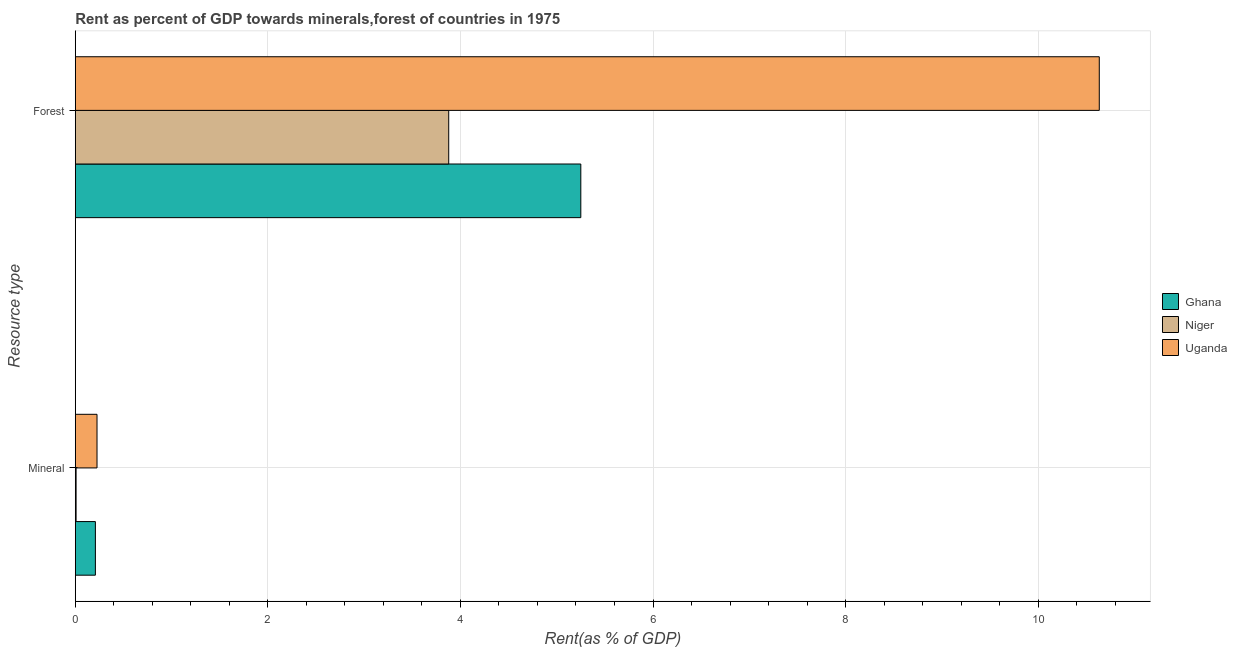How many different coloured bars are there?
Make the answer very short. 3. Are the number of bars per tick equal to the number of legend labels?
Your answer should be very brief. Yes. Are the number of bars on each tick of the Y-axis equal?
Keep it short and to the point. Yes. What is the label of the 1st group of bars from the top?
Ensure brevity in your answer.  Forest. What is the forest rent in Ghana?
Make the answer very short. 5.25. Across all countries, what is the maximum mineral rent?
Offer a terse response. 0.23. Across all countries, what is the minimum forest rent?
Your response must be concise. 3.88. In which country was the mineral rent maximum?
Offer a very short reply. Uganda. In which country was the forest rent minimum?
Your answer should be very brief. Niger. What is the total mineral rent in the graph?
Give a very brief answer. 0.44. What is the difference between the forest rent in Ghana and that in Uganda?
Give a very brief answer. -5.38. What is the difference between the forest rent in Niger and the mineral rent in Ghana?
Keep it short and to the point. 3.67. What is the average forest rent per country?
Keep it short and to the point. 6.59. What is the difference between the mineral rent and forest rent in Ghana?
Offer a terse response. -5.04. In how many countries, is the mineral rent greater than 2.8 %?
Offer a very short reply. 0. What is the ratio of the mineral rent in Niger to that in Uganda?
Your answer should be compact. 0.04. Is the mineral rent in Uganda less than that in Ghana?
Your answer should be very brief. No. In how many countries, is the mineral rent greater than the average mineral rent taken over all countries?
Your answer should be very brief. 2. What does the 3rd bar from the top in Forest represents?
Offer a very short reply. Ghana. What does the 2nd bar from the bottom in Forest represents?
Your answer should be compact. Niger. Are the values on the major ticks of X-axis written in scientific E-notation?
Your answer should be compact. No. Does the graph contain any zero values?
Offer a very short reply. No. Does the graph contain grids?
Give a very brief answer. Yes. Where does the legend appear in the graph?
Offer a terse response. Center right. How many legend labels are there?
Your answer should be very brief. 3. What is the title of the graph?
Your response must be concise. Rent as percent of GDP towards minerals,forest of countries in 1975. What is the label or title of the X-axis?
Your answer should be compact. Rent(as % of GDP). What is the label or title of the Y-axis?
Provide a succinct answer. Resource type. What is the Rent(as % of GDP) of Ghana in Mineral?
Your answer should be very brief. 0.21. What is the Rent(as % of GDP) of Niger in Mineral?
Give a very brief answer. 0.01. What is the Rent(as % of GDP) of Uganda in Mineral?
Offer a terse response. 0.23. What is the Rent(as % of GDP) of Ghana in Forest?
Offer a very short reply. 5.25. What is the Rent(as % of GDP) of Niger in Forest?
Ensure brevity in your answer.  3.88. What is the Rent(as % of GDP) of Uganda in Forest?
Your answer should be compact. 10.63. Across all Resource type, what is the maximum Rent(as % of GDP) of Ghana?
Your answer should be very brief. 5.25. Across all Resource type, what is the maximum Rent(as % of GDP) in Niger?
Your answer should be compact. 3.88. Across all Resource type, what is the maximum Rent(as % of GDP) in Uganda?
Your answer should be very brief. 10.63. Across all Resource type, what is the minimum Rent(as % of GDP) of Ghana?
Offer a terse response. 0.21. Across all Resource type, what is the minimum Rent(as % of GDP) of Niger?
Offer a terse response. 0.01. Across all Resource type, what is the minimum Rent(as % of GDP) in Uganda?
Offer a very short reply. 0.23. What is the total Rent(as % of GDP) of Ghana in the graph?
Give a very brief answer. 5.46. What is the total Rent(as % of GDP) of Niger in the graph?
Give a very brief answer. 3.89. What is the total Rent(as % of GDP) in Uganda in the graph?
Your answer should be compact. 10.86. What is the difference between the Rent(as % of GDP) of Ghana in Mineral and that in Forest?
Offer a very short reply. -5.04. What is the difference between the Rent(as % of GDP) in Niger in Mineral and that in Forest?
Keep it short and to the point. -3.87. What is the difference between the Rent(as % of GDP) of Uganda in Mineral and that in Forest?
Offer a terse response. -10.41. What is the difference between the Rent(as % of GDP) of Ghana in Mineral and the Rent(as % of GDP) of Niger in Forest?
Provide a short and direct response. -3.67. What is the difference between the Rent(as % of GDP) in Ghana in Mineral and the Rent(as % of GDP) in Uganda in Forest?
Keep it short and to the point. -10.43. What is the difference between the Rent(as % of GDP) of Niger in Mineral and the Rent(as % of GDP) of Uganda in Forest?
Provide a succinct answer. -10.63. What is the average Rent(as % of GDP) of Ghana per Resource type?
Your answer should be compact. 2.73. What is the average Rent(as % of GDP) of Niger per Resource type?
Provide a short and direct response. 1.94. What is the average Rent(as % of GDP) in Uganda per Resource type?
Your response must be concise. 5.43. What is the difference between the Rent(as % of GDP) of Ghana and Rent(as % of GDP) of Niger in Mineral?
Ensure brevity in your answer.  0.2. What is the difference between the Rent(as % of GDP) in Ghana and Rent(as % of GDP) in Uganda in Mineral?
Provide a succinct answer. -0.02. What is the difference between the Rent(as % of GDP) in Niger and Rent(as % of GDP) in Uganda in Mineral?
Offer a terse response. -0.22. What is the difference between the Rent(as % of GDP) of Ghana and Rent(as % of GDP) of Niger in Forest?
Provide a short and direct response. 1.37. What is the difference between the Rent(as % of GDP) of Ghana and Rent(as % of GDP) of Uganda in Forest?
Keep it short and to the point. -5.38. What is the difference between the Rent(as % of GDP) in Niger and Rent(as % of GDP) in Uganda in Forest?
Give a very brief answer. -6.76. What is the ratio of the Rent(as % of GDP) in Ghana in Mineral to that in Forest?
Offer a very short reply. 0.04. What is the ratio of the Rent(as % of GDP) of Niger in Mineral to that in Forest?
Provide a succinct answer. 0. What is the ratio of the Rent(as % of GDP) of Uganda in Mineral to that in Forest?
Provide a short and direct response. 0.02. What is the difference between the highest and the second highest Rent(as % of GDP) in Ghana?
Give a very brief answer. 5.04. What is the difference between the highest and the second highest Rent(as % of GDP) of Niger?
Your answer should be very brief. 3.87. What is the difference between the highest and the second highest Rent(as % of GDP) in Uganda?
Ensure brevity in your answer.  10.41. What is the difference between the highest and the lowest Rent(as % of GDP) in Ghana?
Make the answer very short. 5.04. What is the difference between the highest and the lowest Rent(as % of GDP) of Niger?
Give a very brief answer. 3.87. What is the difference between the highest and the lowest Rent(as % of GDP) of Uganda?
Keep it short and to the point. 10.41. 